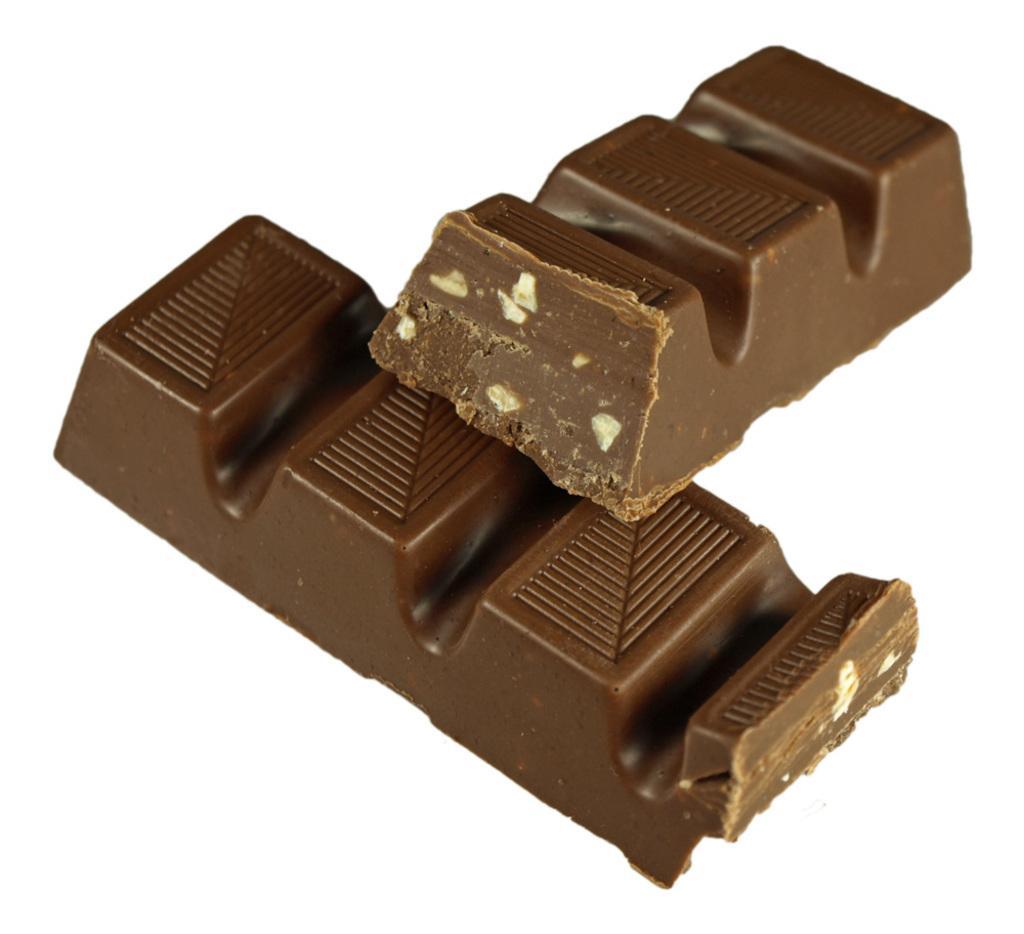Could you give a brief overview of what you see in this image? In this image I can see the chocolates which are in brown color. These are on the white color surface. 